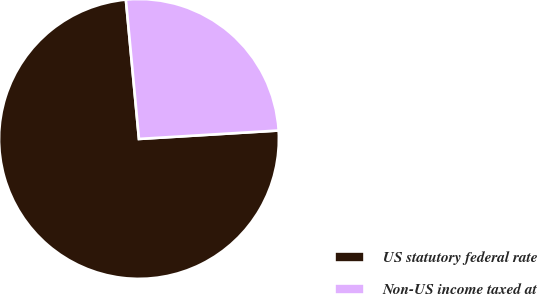Convert chart. <chart><loc_0><loc_0><loc_500><loc_500><pie_chart><fcel>US statutory federal rate<fcel>Non-US income taxed at<nl><fcel>74.47%<fcel>25.53%<nl></chart> 